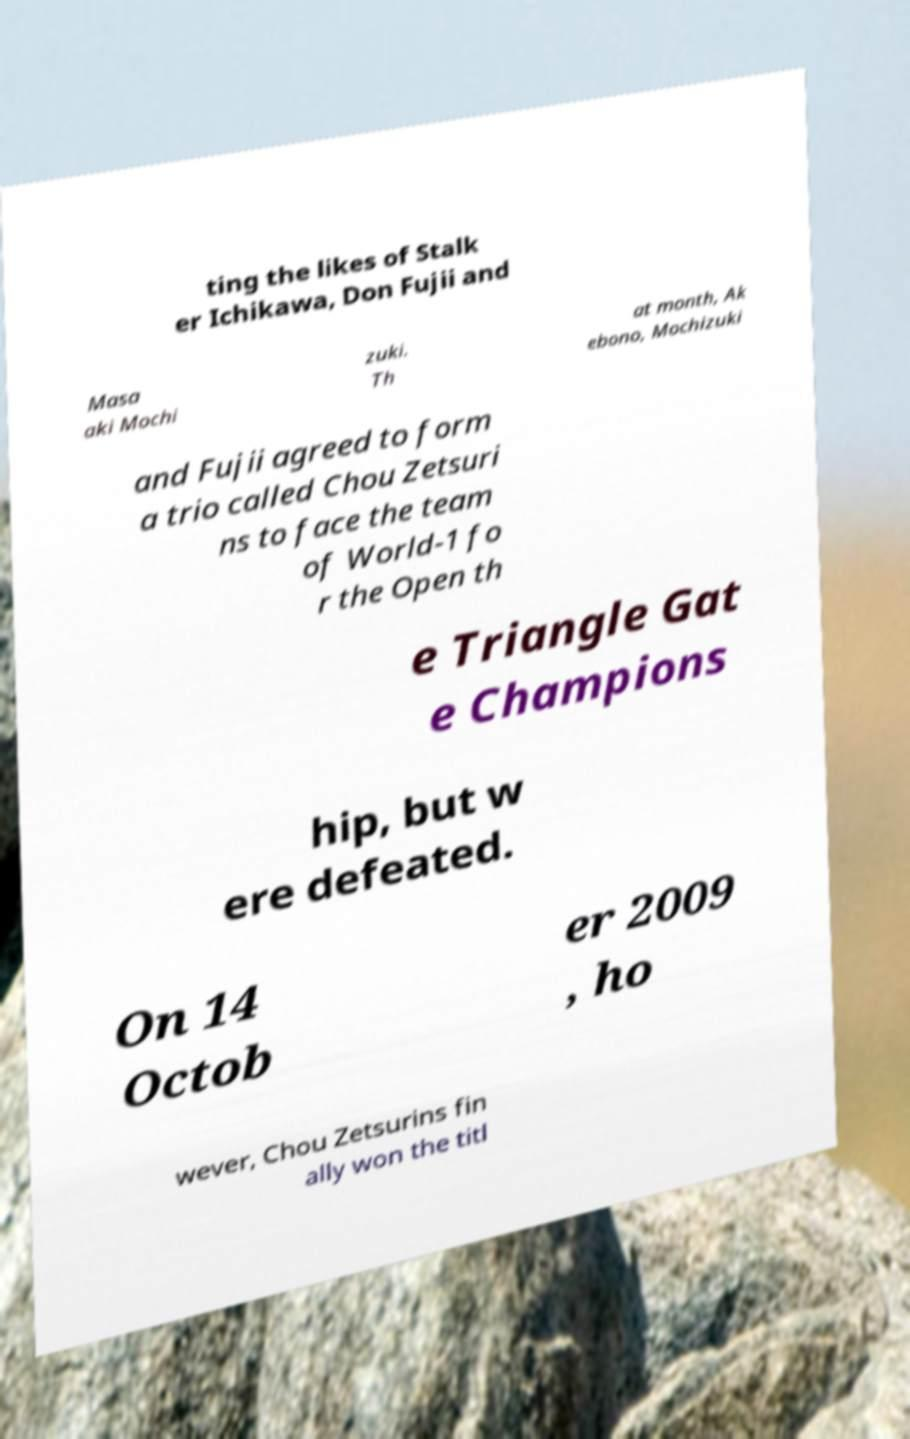Please identify and transcribe the text found in this image. ting the likes of Stalk er Ichikawa, Don Fujii and Masa aki Mochi zuki. Th at month, Ak ebono, Mochizuki and Fujii agreed to form a trio called Chou Zetsuri ns to face the team of World-1 fo r the Open th e Triangle Gat e Champions hip, but w ere defeated. On 14 Octob er 2009 , ho wever, Chou Zetsurins fin ally won the titl 